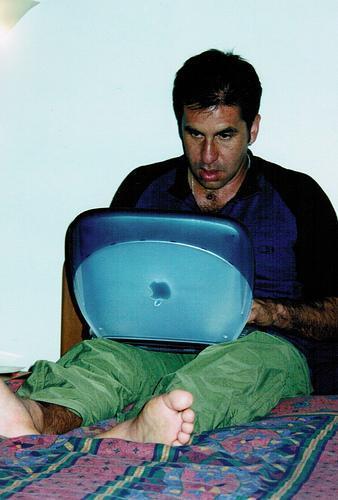How many laptops are in the photo?
Give a very brief answer. 1. 